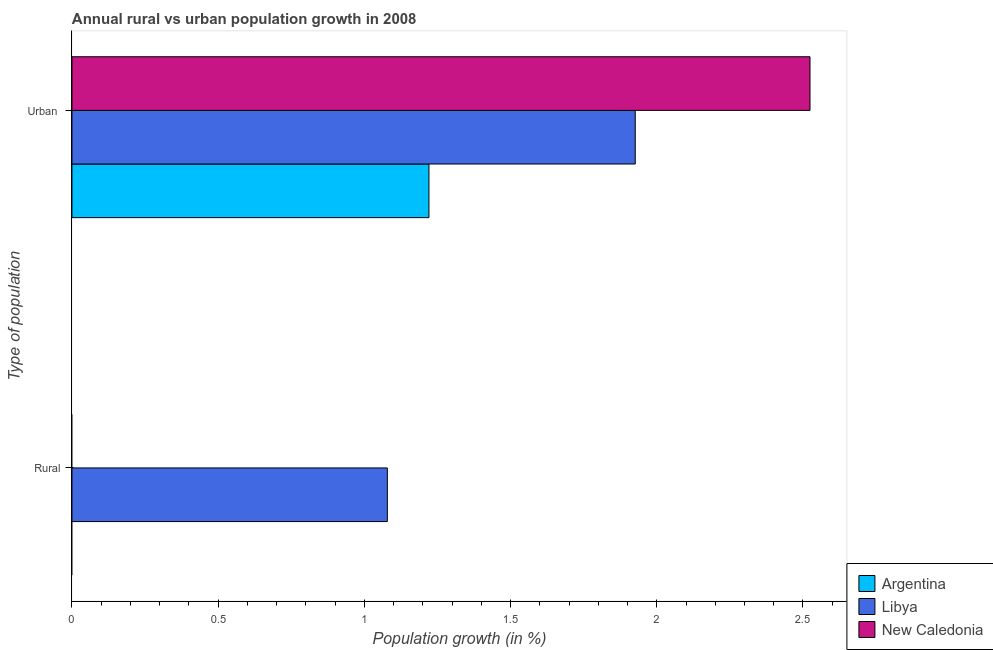Are the number of bars per tick equal to the number of legend labels?
Provide a succinct answer. No. Are the number of bars on each tick of the Y-axis equal?
Ensure brevity in your answer.  No. What is the label of the 1st group of bars from the top?
Provide a succinct answer. Urban . What is the urban population growth in Libya?
Give a very brief answer. 1.93. Across all countries, what is the maximum urban population growth?
Ensure brevity in your answer.  2.52. Across all countries, what is the minimum urban population growth?
Provide a short and direct response. 1.22. In which country was the urban population growth maximum?
Ensure brevity in your answer.  New Caledonia. What is the total urban population growth in the graph?
Your response must be concise. 5.67. What is the difference between the urban population growth in New Caledonia and that in Argentina?
Keep it short and to the point. 1.3. What is the difference between the urban population growth in Libya and the rural population growth in Argentina?
Offer a very short reply. 1.93. What is the average rural population growth per country?
Your answer should be very brief. 0.36. What is the difference between the rural population growth and urban population growth in Libya?
Provide a succinct answer. -0.85. In how many countries, is the urban population growth greater than 2.4 %?
Provide a short and direct response. 1. What is the ratio of the urban population growth in Argentina to that in Libya?
Your response must be concise. 0.63. Is the urban population growth in New Caledonia less than that in Argentina?
Offer a terse response. No. In how many countries, is the rural population growth greater than the average rural population growth taken over all countries?
Keep it short and to the point. 1. How many bars are there?
Your answer should be compact. 4. Are all the bars in the graph horizontal?
Offer a terse response. Yes. What is the difference between two consecutive major ticks on the X-axis?
Provide a succinct answer. 0.5. Are the values on the major ticks of X-axis written in scientific E-notation?
Ensure brevity in your answer.  No. Does the graph contain any zero values?
Your answer should be compact. Yes. Does the graph contain grids?
Your answer should be very brief. No. How are the legend labels stacked?
Your response must be concise. Vertical. What is the title of the graph?
Offer a very short reply. Annual rural vs urban population growth in 2008. Does "European Union" appear as one of the legend labels in the graph?
Ensure brevity in your answer.  No. What is the label or title of the X-axis?
Provide a succinct answer. Population growth (in %). What is the label or title of the Y-axis?
Provide a short and direct response. Type of population. What is the Population growth (in %) in Libya in Rural?
Offer a terse response. 1.08. What is the Population growth (in %) of Argentina in Urban ?
Provide a succinct answer. 1.22. What is the Population growth (in %) in Libya in Urban ?
Give a very brief answer. 1.93. What is the Population growth (in %) of New Caledonia in Urban ?
Your response must be concise. 2.52. Across all Type of population, what is the maximum Population growth (in %) of Argentina?
Your response must be concise. 1.22. Across all Type of population, what is the maximum Population growth (in %) in Libya?
Keep it short and to the point. 1.93. Across all Type of population, what is the maximum Population growth (in %) of New Caledonia?
Provide a succinct answer. 2.52. Across all Type of population, what is the minimum Population growth (in %) in Argentina?
Your answer should be compact. 0. Across all Type of population, what is the minimum Population growth (in %) in Libya?
Keep it short and to the point. 1.08. Across all Type of population, what is the minimum Population growth (in %) of New Caledonia?
Your answer should be very brief. 0. What is the total Population growth (in %) of Argentina in the graph?
Offer a very short reply. 1.22. What is the total Population growth (in %) in Libya in the graph?
Make the answer very short. 3. What is the total Population growth (in %) of New Caledonia in the graph?
Give a very brief answer. 2.52. What is the difference between the Population growth (in %) in Libya in Rural and that in Urban ?
Your answer should be very brief. -0.85. What is the difference between the Population growth (in %) of Libya in Rural and the Population growth (in %) of New Caledonia in Urban ?
Make the answer very short. -1.45. What is the average Population growth (in %) of Argentina per Type of population?
Provide a short and direct response. 0.61. What is the average Population growth (in %) of Libya per Type of population?
Your answer should be very brief. 1.5. What is the average Population growth (in %) in New Caledonia per Type of population?
Provide a succinct answer. 1.26. What is the difference between the Population growth (in %) in Argentina and Population growth (in %) in Libya in Urban ?
Offer a very short reply. -0.71. What is the difference between the Population growth (in %) of Argentina and Population growth (in %) of New Caledonia in Urban ?
Your answer should be compact. -1.3. What is the difference between the Population growth (in %) in Libya and Population growth (in %) in New Caledonia in Urban ?
Keep it short and to the point. -0.6. What is the ratio of the Population growth (in %) in Libya in Rural to that in Urban ?
Make the answer very short. 0.56. What is the difference between the highest and the second highest Population growth (in %) in Libya?
Your response must be concise. 0.85. What is the difference between the highest and the lowest Population growth (in %) of Argentina?
Keep it short and to the point. 1.22. What is the difference between the highest and the lowest Population growth (in %) of Libya?
Make the answer very short. 0.85. What is the difference between the highest and the lowest Population growth (in %) of New Caledonia?
Offer a terse response. 2.52. 